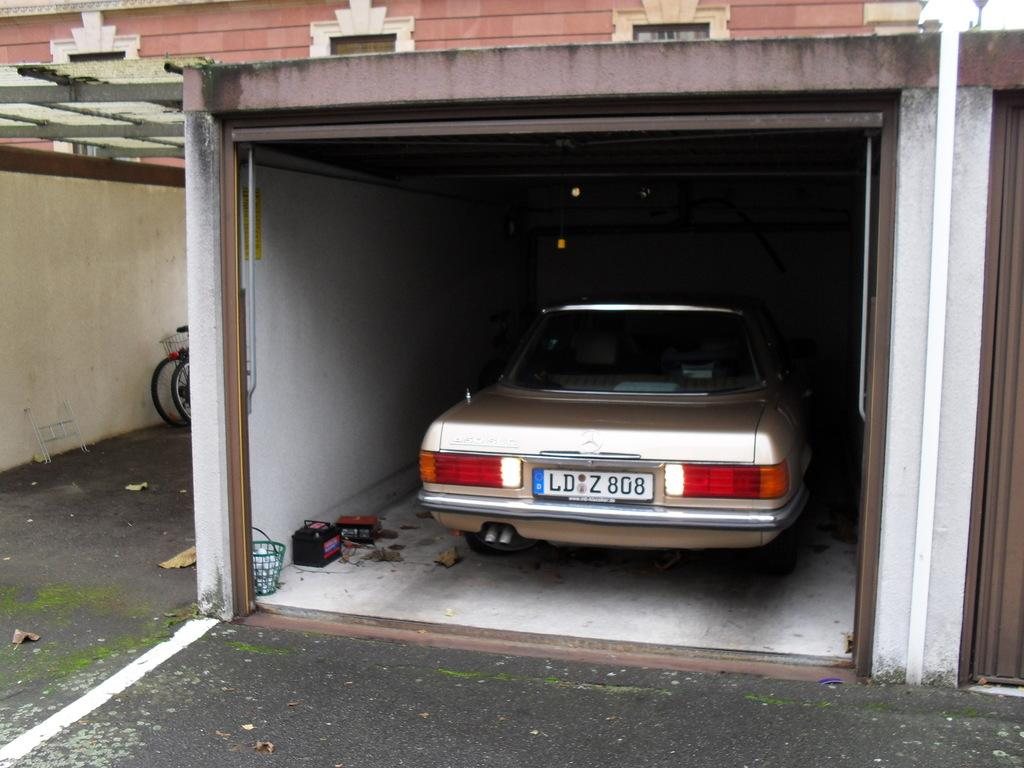What type of vehicle is in the garage in the image? The facts do not specify the type of vehicle in the garage. What additional mode of transportation can be seen in the image? There are bicycles in the image. What other objects are present on the ground in the image? There are other objects on the ground, but their specific nature is not mentioned in the facts. Can you describe a feature of the ground in the image? There is a white color line on the ground. How many fingers can be seen on the bicycles in the image? There are no fingers present on the bicycles in the image; they are inanimate objects. 